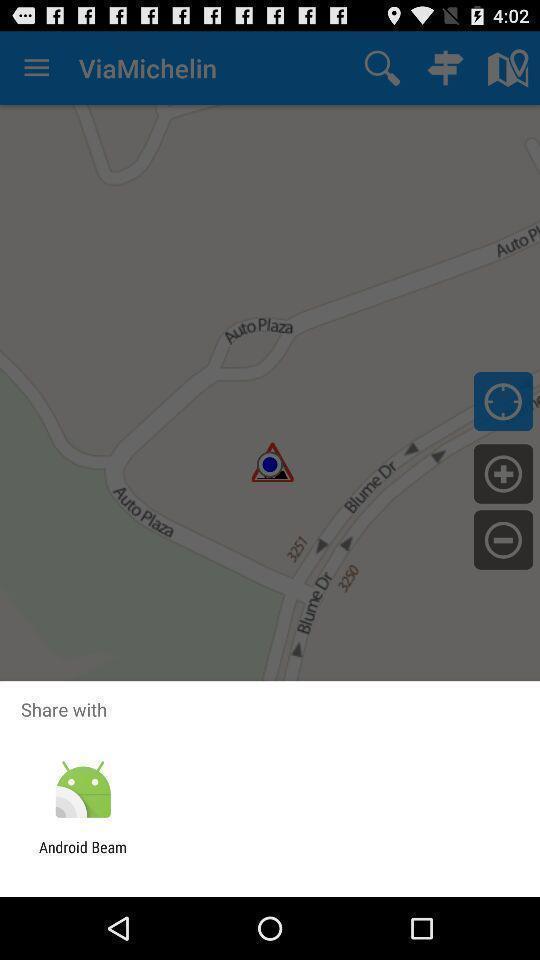Describe this image in words. Push up message for sharing data via social network. 